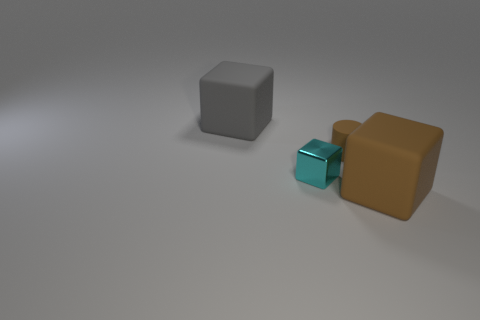There is a brown cube; does it have the same size as the cyan metal object in front of the tiny brown cylinder?
Make the answer very short. No. There is a big thing in front of the gray object; what is it made of?
Offer a very short reply. Rubber. Are there the same number of tiny rubber things that are to the right of the small brown cylinder and small brown cylinders?
Your answer should be very brief. No. Is the cyan metallic block the same size as the cylinder?
Your response must be concise. Yes. Is there a rubber block that is in front of the large matte cube left of the large rubber thing right of the brown matte cylinder?
Offer a terse response. Yes. There is a cyan object that is the same shape as the large gray matte object; what material is it?
Give a very brief answer. Metal. What number of large brown cubes are to the right of the big thing right of the gray object?
Provide a short and direct response. 0. There is a brown matte thing that is on the left side of the large matte thing on the right side of the big rubber object behind the large brown matte cube; how big is it?
Your answer should be compact. Small. What color is the large block that is behind the large cube that is on the right side of the big gray matte object?
Offer a terse response. Gray. What number of other objects are the same material as the small brown cylinder?
Your answer should be compact. 2. 